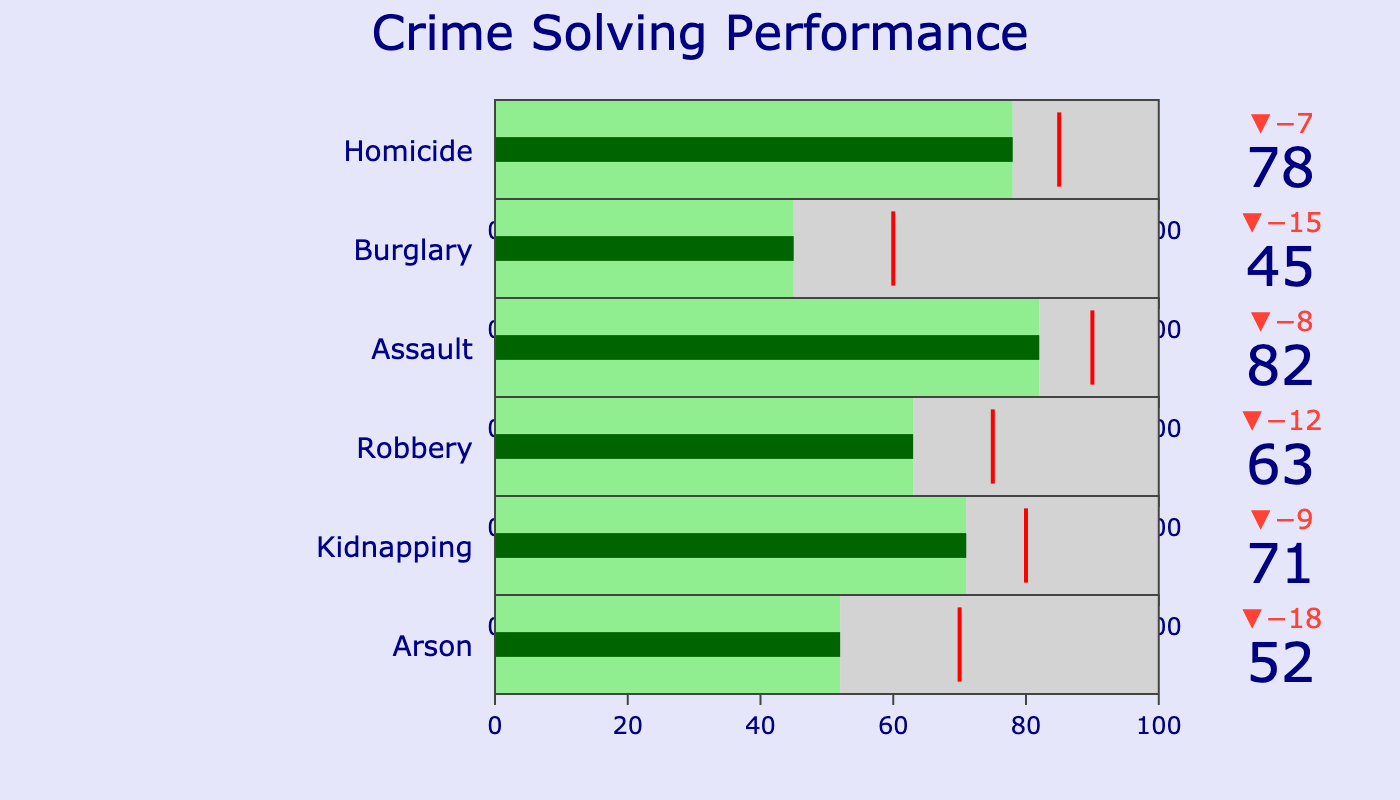what is the total number of crimes solved for homicide? The bullet chart for homicide shows that the number of solved cases is 78, so the total number is 78.
Answer: 78 Which crime category has the closest number of solved cases to its target? To find out which category has the smallest difference between solved cases and its target, we can compare the delta values. Homicide has a target of 85 and solved cases of 78, making a difference of 7. Burglary has a difference of 15 (45 solved vs. 60 target), Assault has a difference of 8 (82 solved vs. 90 target), Robbery has a difference of 12 (63 solved vs. 75 target), Kidnapping has a difference of 9 (71 solved vs. 80 target), and Arson has a difference of 18 (52 solved vs. 70 target). Therefore, homicide has the closest number of solved cases to its target.
Answer: Homicide What crime category has the highest number of unsolved cases? By visually inspecting the bullet chart, we can see that burglary has the highest number of unsolved cases at 55.
Answer: Burglary How many more solved cases are needed for arson to reach its target? Arson's target is 70, while the number of solved cases is 52. Therefore, to reach its target, arson needs 70 - 52 = 18 more solved cases.
Answer: 18 Which crime category has the largest difference between solved and unsolved cases? To find this, we can look at the difference for each category: Homicide (78 - 22 = 56), Burglary (45 - 55 = -10), Assault (82 - 18 = 64), Robbery (63 - 37 = 26), Kidnapping (71 - 29 = 42), Arson (52 - 48 = 4). Assault has the largest difference at 64.
Answer: Assault Is the current performance of solving kidnapping cases above or below the target? The solved number for kidnapping is 71, while the target is set at 80. Since 71 is less than 80, the performance is below the target.
Answer: Below How many categories have a target greater than 70? By checking the target values for each category — Homicide (85), Burglary (60), Assault (90), Robbery (75), Kidnapping (80), and Arson (70) — there are four categories with targets greater than 70: Homicide, Assault, Robbery, and Kidnapping.
Answer: 4 What is the total number of solved cases across all crime categories? To get the total number of solved cases, we sum up the solved values across all categories: 78 (Homicide) + 45 (Burglary) + 82 (Assault) + 63 (Robbery) + 71 (Kidnapping) + 52 (Arson) = 391.
Answer: 391 Which crime category's performance is furthest from its target? To find this, we consider the delta values again: Homicide (7), Burglary (15), Assault (8), Robbery (12), Kidnapping (9), and Arson (18). Arson has the largest delta, meaning its performance is furthest from its target.
Answer: Arson 